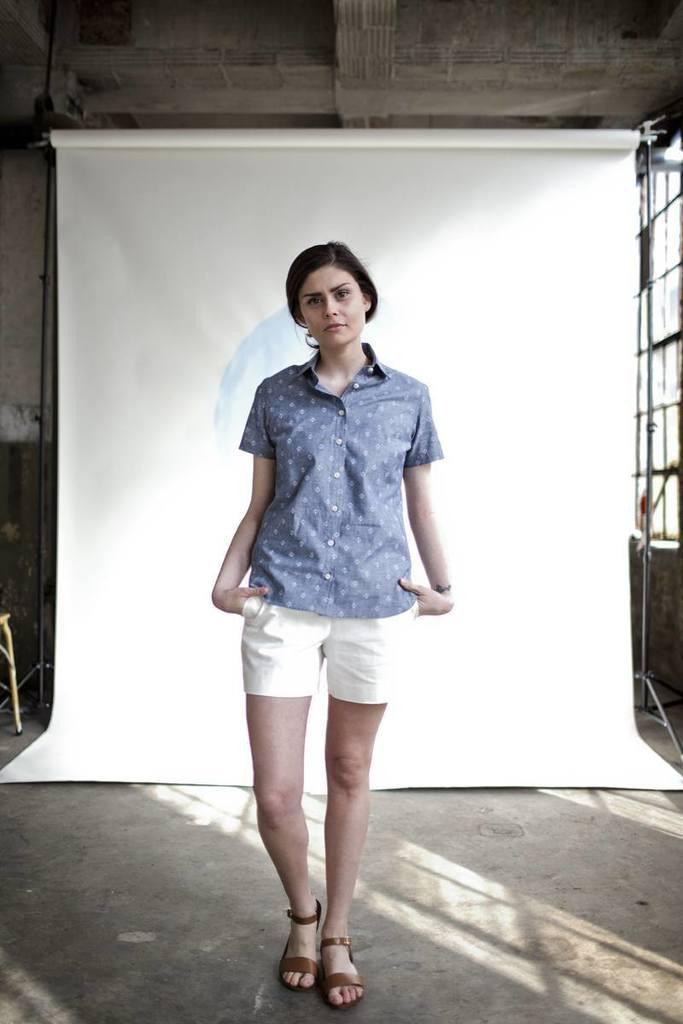What is the main subject of the image? There is a woman standing in the image. What is the woman standing on? The woman is standing on the floor. What can be seen in the background of the image? There is a banner and a wall in the background of the image. What type of underwear is the woman wearing in the image? There is no information about the woman's underwear in the image, so it cannot be determined. 